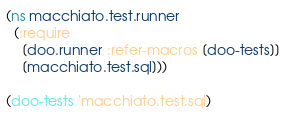Convert code to text. <code><loc_0><loc_0><loc_500><loc_500><_Clojure_>(ns macchiato.test.runner
  (:require
    [doo.runner :refer-macros [doo-tests]]
    [macchiato.test.sql]))

(doo-tests 'macchiato.test.sql)
</code> 